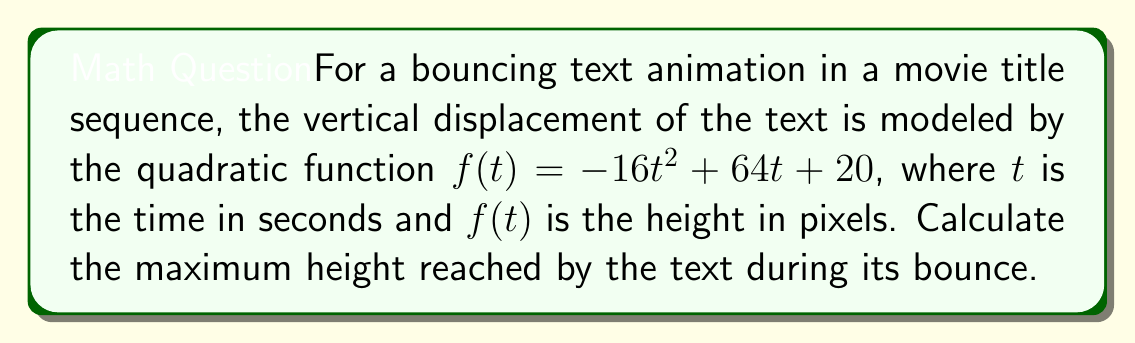Could you help me with this problem? To find the maximum height of the bouncing text, we need to find the vertex of the parabola described by the quadratic function. The general form of a quadratic function is $f(t) = at^2 + bt + c$, where $a$, $b$, and $c$ are constants and $a \neq 0$.

Given function: $f(t) = -16t^2 + 64t + 20$

1. Identify the coefficients:
   $a = -16$, $b = 64$, $c = 20$

2. For a quadratic function, the t-coordinate of the vertex is given by $t = -\frac{b}{2a}$:
   
   $t = -\frac{64}{2(-16)} = -\frac{64}{-32} = 2$

3. To find the maximum height (y-coordinate of the vertex), substitute this t-value into the original function:

   $f(2) = -16(2)^2 + 64(2) + 20$
   $    = -16(4) + 128 + 20$
   $    = -64 + 128 + 20$
   $    = 84$

Therefore, the maximum height reached by the text is 84 pixels.
Answer: The maximum height reached by the text during its bounce is 84 pixels. 